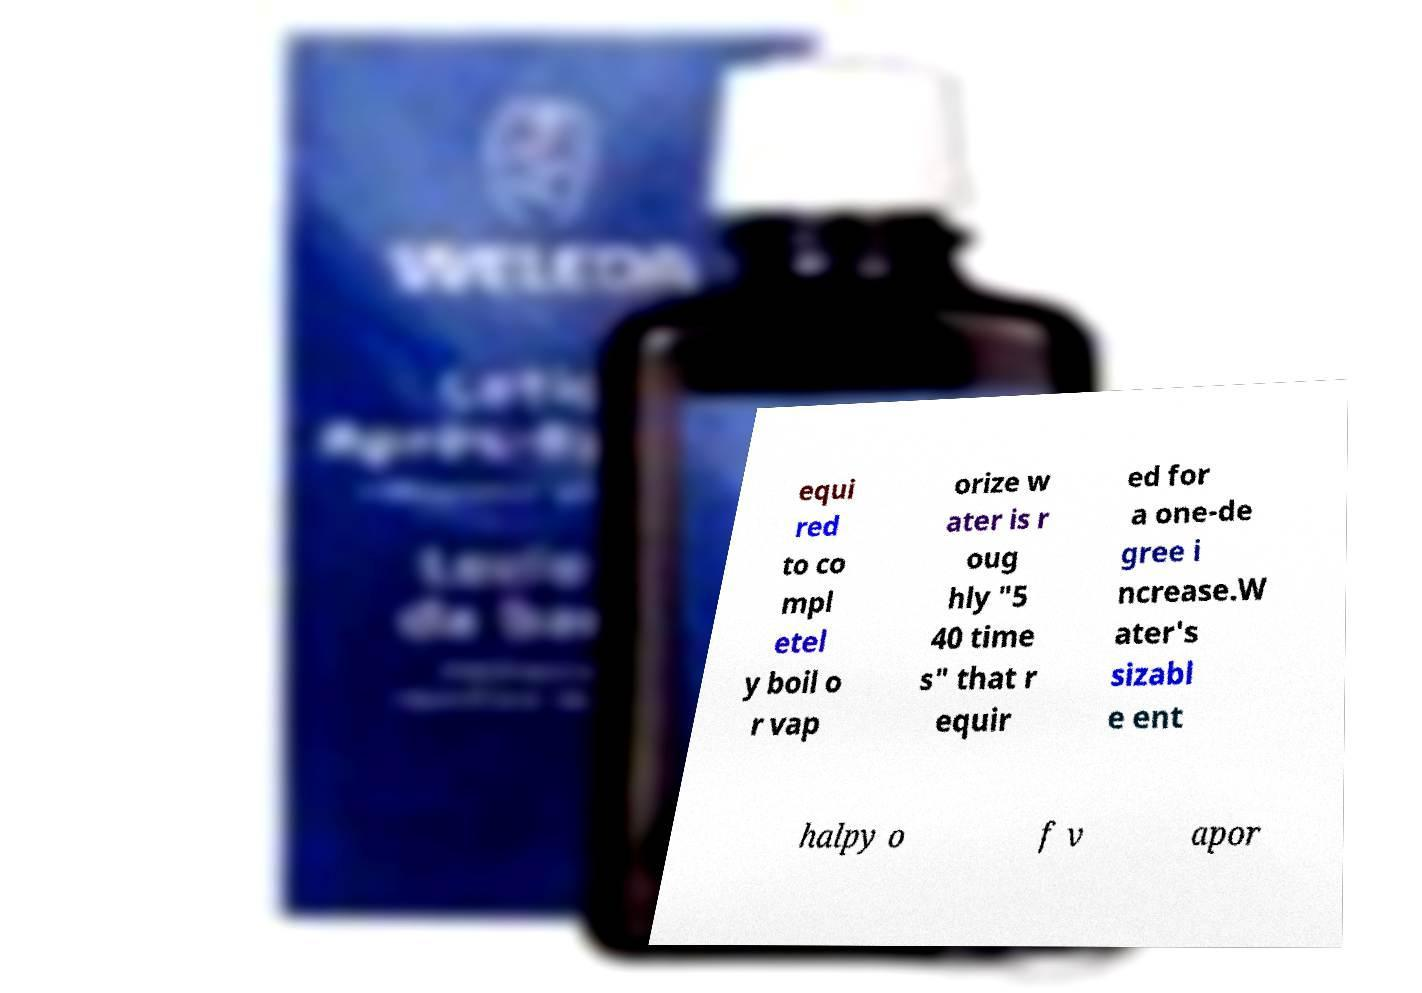Could you extract and type out the text from this image? equi red to co mpl etel y boil o r vap orize w ater is r oug hly "5 40 time s" that r equir ed for a one-de gree i ncrease.W ater's sizabl e ent halpy o f v apor 